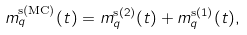<formula> <loc_0><loc_0><loc_500><loc_500>m ^ { \text {s(MC)} } _ { q } ( t ) = m ^ { \text {s} ( 2 ) } _ { q } ( t ) + m ^ { \text {s} ( 1 ) } _ { q } ( t ) ,</formula> 